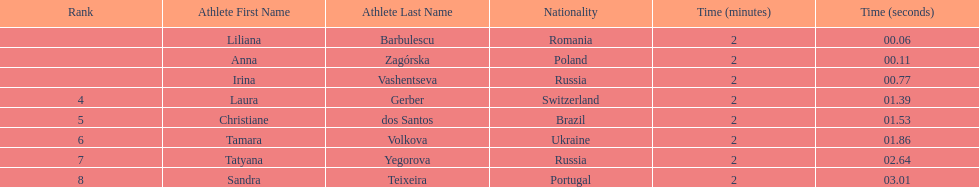How many runners finished with their time below 2:01? 3. 